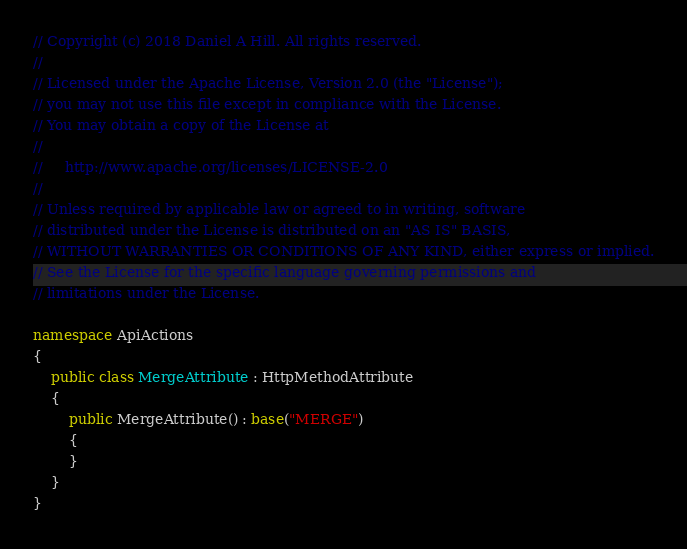<code> <loc_0><loc_0><loc_500><loc_500><_C#_>// Copyright (c) 2018 Daniel A Hill. All rights reserved.
// 
// Licensed under the Apache License, Version 2.0 (the "License");
// you may not use this file except in compliance with the License.
// You may obtain a copy of the License at
// 
//     http://www.apache.org/licenses/LICENSE-2.0
// 
// Unless required by applicable law or agreed to in writing, software
// distributed under the License is distributed on an "AS IS" BASIS,
// WITHOUT WARRANTIES OR CONDITIONS OF ANY KIND, either express or implied.
// See the License for the specific language governing permissions and
// limitations under the License.

namespace ApiActions
{
    public class MergeAttribute : HttpMethodAttribute
    {
        public MergeAttribute() : base("MERGE")
        {
        }
    }
}</code> 